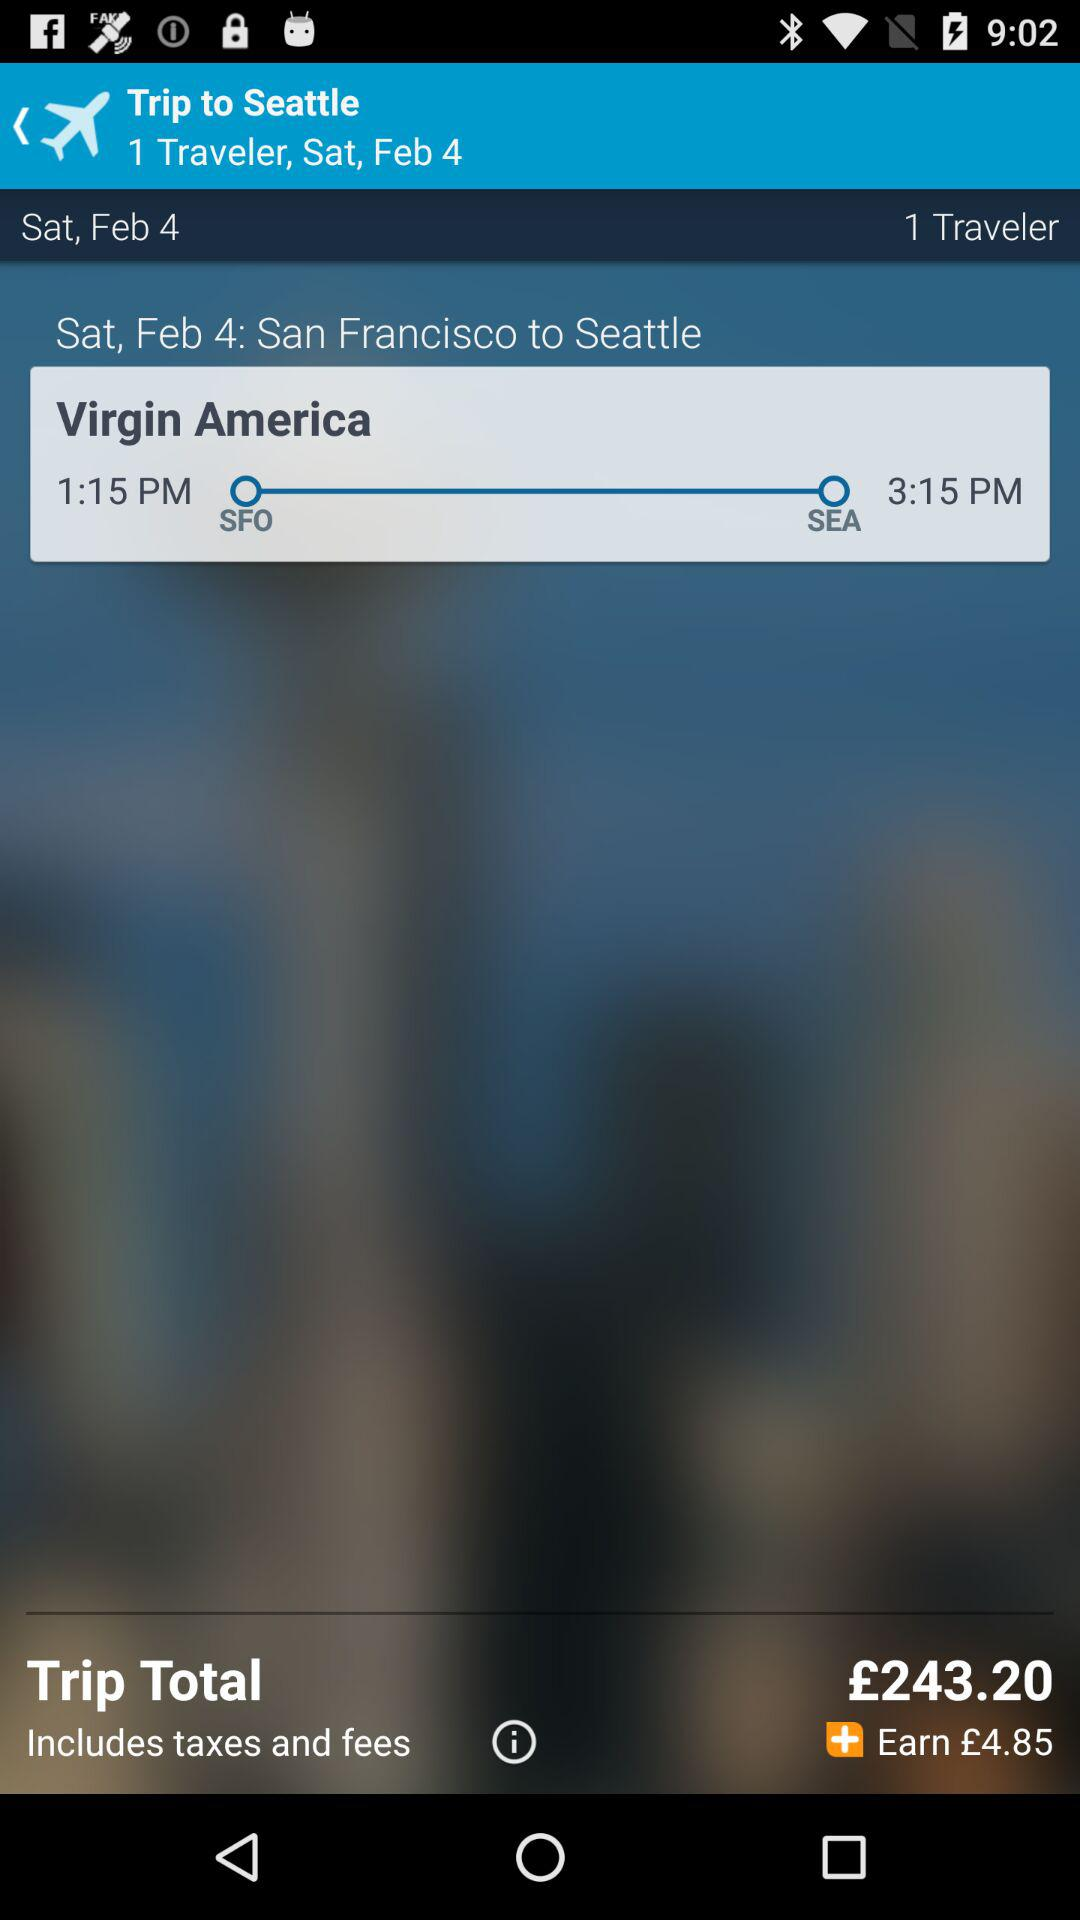What is the departure time? The departure time is 1:15 PM. 